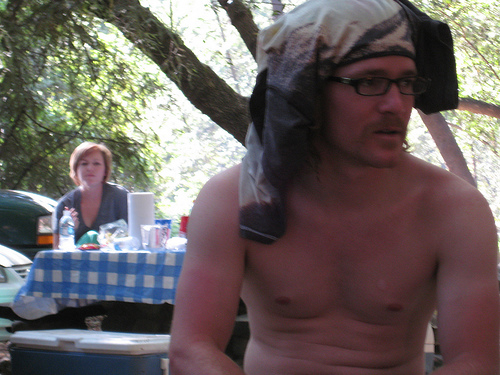<image>
Is the shirt on the head? Yes. Looking at the image, I can see the shirt is positioned on top of the head, with the head providing support. 